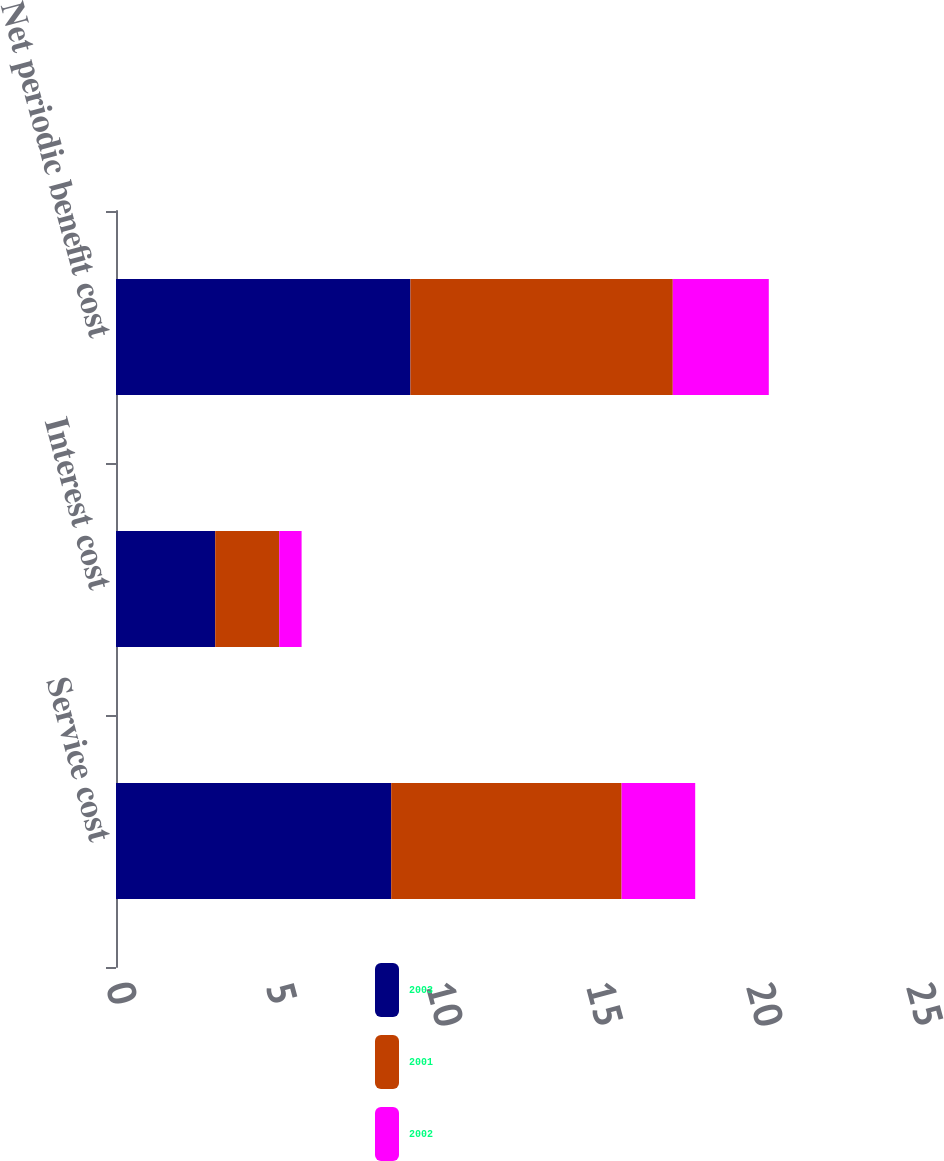Convert chart. <chart><loc_0><loc_0><loc_500><loc_500><stacked_bar_chart><ecel><fcel>Service cost<fcel>Interest cost<fcel>Net periodic benefit cost<nl><fcel>2003<fcel>8.6<fcel>3.1<fcel>9.2<nl><fcel>2001<fcel>7.2<fcel>2<fcel>8.2<nl><fcel>2002<fcel>2.3<fcel>0.7<fcel>3<nl></chart> 